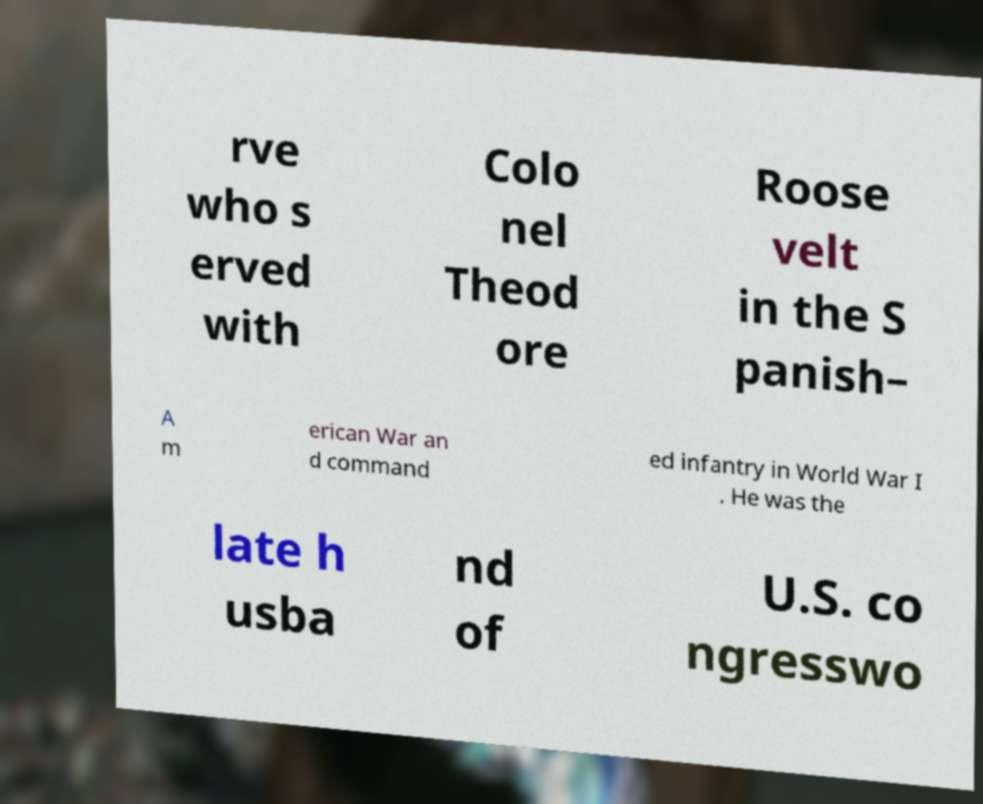For documentation purposes, I need the text within this image transcribed. Could you provide that? rve who s erved with Colo nel Theod ore Roose velt in the S panish– A m erican War an d command ed infantry in World War I . He was the late h usba nd of U.S. co ngresswo 